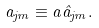<formula> <loc_0><loc_0><loc_500><loc_500>a _ { j m } \equiv a { \hat { a } } _ { j m } .</formula> 